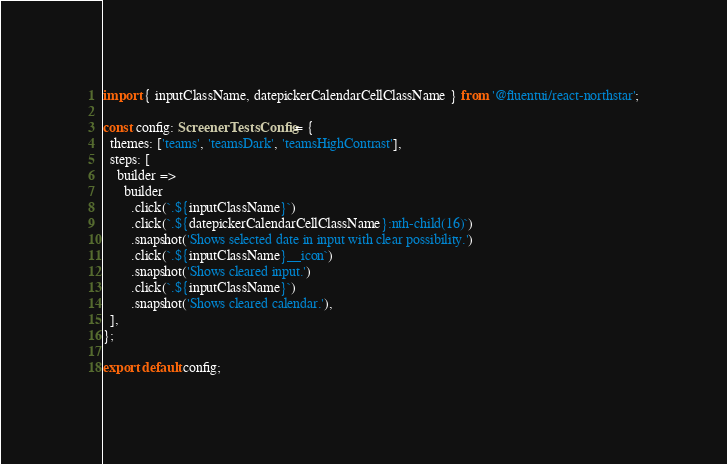Convert code to text. <code><loc_0><loc_0><loc_500><loc_500><_TypeScript_>import { inputClassName, datepickerCalendarCellClassName } from '@fluentui/react-northstar';

const config: ScreenerTestsConfig = {
  themes: ['teams', 'teamsDark', 'teamsHighContrast'],
  steps: [
    builder =>
      builder
        .click(`.${inputClassName}`)
        .click(`.${datepickerCalendarCellClassName}:nth-child(16)`)
        .snapshot('Shows selected date in input with clear possibility.')
        .click(`.${inputClassName}__icon`)
        .snapshot('Shows cleared input.')
        .click(`.${inputClassName}`)
        .snapshot('Shows cleared calendar.'),
  ],
};

export default config;
</code> 